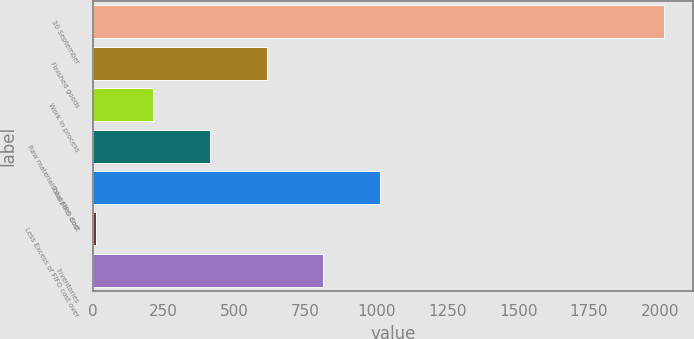Convert chart to OTSL. <chart><loc_0><loc_0><loc_500><loc_500><bar_chart><fcel>30 September<fcel>Finished goods<fcel>Work in process<fcel>Raw materials supplies and<fcel>Total FIFO Cost<fcel>Less Excess of FIFO cost over<fcel>Inventories<nl><fcel>2016<fcel>612.99<fcel>212.13<fcel>412.56<fcel>1013.85<fcel>11.7<fcel>813.42<nl></chart> 